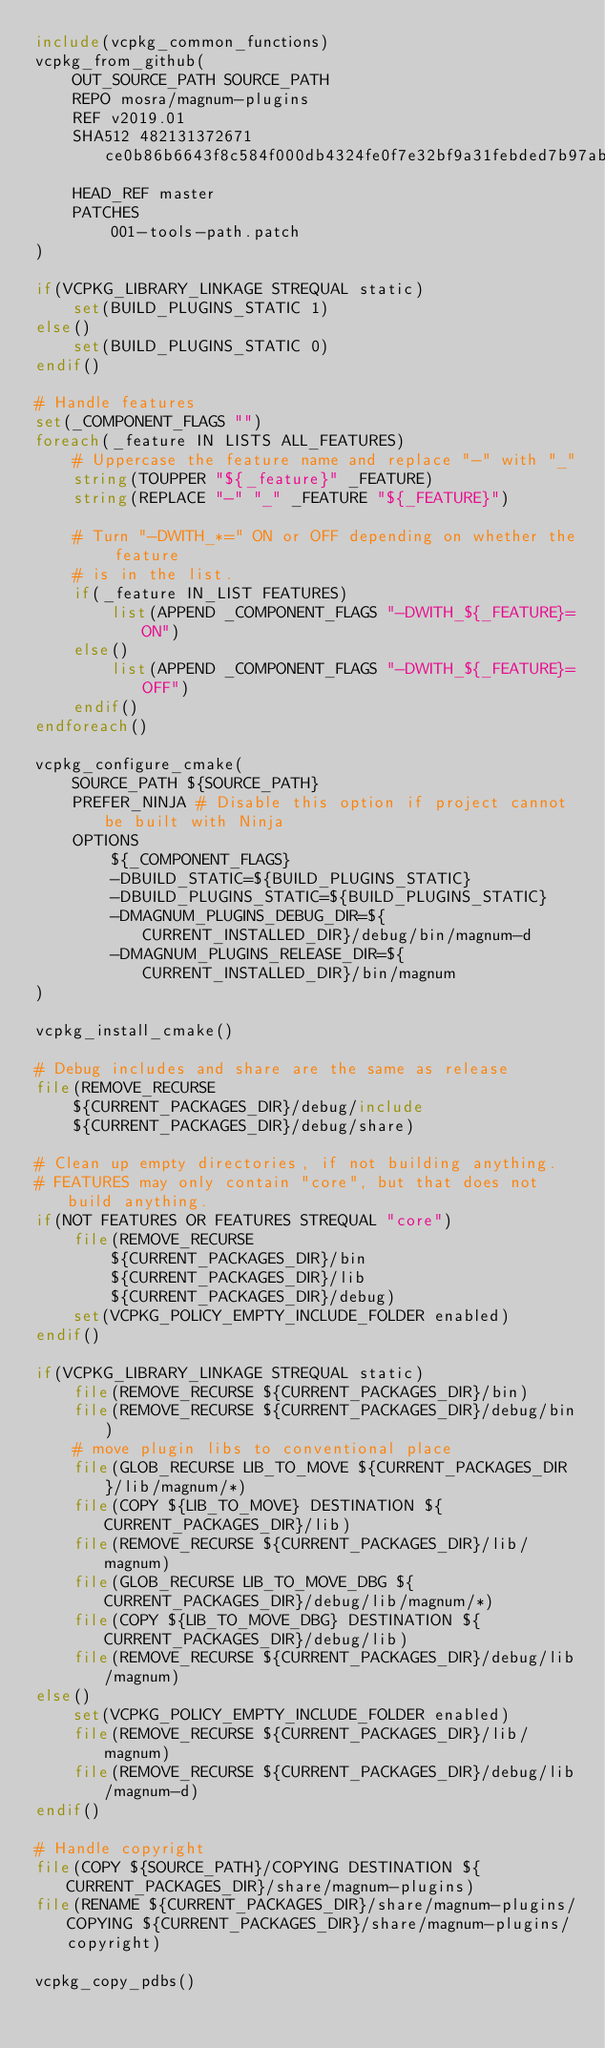Convert code to text. <code><loc_0><loc_0><loc_500><loc_500><_CMake_>include(vcpkg_common_functions)
vcpkg_from_github(
    OUT_SOURCE_PATH SOURCE_PATH
    REPO mosra/magnum-plugins
    REF v2019.01
    SHA512 482131372671ce0b86b6643f8c584f000db4324fe0f7e32bf9a31febded7b97ab7e947028fe21ce649554d2cff2bc11dfd94fad0006c465911c9f44b28c2d2a5
    HEAD_REF master
    PATCHES
        001-tools-path.patch
)

if(VCPKG_LIBRARY_LINKAGE STREQUAL static)
    set(BUILD_PLUGINS_STATIC 1)
else()
    set(BUILD_PLUGINS_STATIC 0)
endif()

# Handle features
set(_COMPONENT_FLAGS "")
foreach(_feature IN LISTS ALL_FEATURES)
    # Uppercase the feature name and replace "-" with "_"
    string(TOUPPER "${_feature}" _FEATURE)
    string(REPLACE "-" "_" _FEATURE "${_FEATURE}")

    # Turn "-DWITH_*=" ON or OFF depending on whether the feature
    # is in the list.
    if(_feature IN_LIST FEATURES)
        list(APPEND _COMPONENT_FLAGS "-DWITH_${_FEATURE}=ON")
    else()
        list(APPEND _COMPONENT_FLAGS "-DWITH_${_FEATURE}=OFF")
    endif()
endforeach()

vcpkg_configure_cmake(
    SOURCE_PATH ${SOURCE_PATH}
    PREFER_NINJA # Disable this option if project cannot be built with Ninja
    OPTIONS
        ${_COMPONENT_FLAGS}
        -DBUILD_STATIC=${BUILD_PLUGINS_STATIC}
        -DBUILD_PLUGINS_STATIC=${BUILD_PLUGINS_STATIC}
        -DMAGNUM_PLUGINS_DEBUG_DIR=${CURRENT_INSTALLED_DIR}/debug/bin/magnum-d
        -DMAGNUM_PLUGINS_RELEASE_DIR=${CURRENT_INSTALLED_DIR}/bin/magnum
)

vcpkg_install_cmake()

# Debug includes and share are the same as release
file(REMOVE_RECURSE
    ${CURRENT_PACKAGES_DIR}/debug/include
    ${CURRENT_PACKAGES_DIR}/debug/share)

# Clean up empty directories, if not building anything.
# FEATURES may only contain "core", but that does not build anything.
if(NOT FEATURES OR FEATURES STREQUAL "core")
    file(REMOVE_RECURSE
        ${CURRENT_PACKAGES_DIR}/bin
        ${CURRENT_PACKAGES_DIR}/lib
        ${CURRENT_PACKAGES_DIR}/debug)
    set(VCPKG_POLICY_EMPTY_INCLUDE_FOLDER enabled)
endif()

if(VCPKG_LIBRARY_LINKAGE STREQUAL static)
    file(REMOVE_RECURSE ${CURRENT_PACKAGES_DIR}/bin)
    file(REMOVE_RECURSE ${CURRENT_PACKAGES_DIR}/debug/bin)
    # move plugin libs to conventional place
    file(GLOB_RECURSE LIB_TO_MOVE ${CURRENT_PACKAGES_DIR}/lib/magnum/*)
    file(COPY ${LIB_TO_MOVE} DESTINATION ${CURRENT_PACKAGES_DIR}/lib)
    file(REMOVE_RECURSE ${CURRENT_PACKAGES_DIR}/lib/magnum)
    file(GLOB_RECURSE LIB_TO_MOVE_DBG ${CURRENT_PACKAGES_DIR}/debug/lib/magnum/*)
    file(COPY ${LIB_TO_MOVE_DBG} DESTINATION ${CURRENT_PACKAGES_DIR}/debug/lib)
    file(REMOVE_RECURSE ${CURRENT_PACKAGES_DIR}/debug/lib/magnum)
else()
    set(VCPKG_POLICY_EMPTY_INCLUDE_FOLDER enabled)
    file(REMOVE_RECURSE ${CURRENT_PACKAGES_DIR}/lib/magnum)
    file(REMOVE_RECURSE ${CURRENT_PACKAGES_DIR}/debug/lib/magnum-d)
endif()

# Handle copyright
file(COPY ${SOURCE_PATH}/COPYING DESTINATION ${CURRENT_PACKAGES_DIR}/share/magnum-plugins)
file(RENAME ${CURRENT_PACKAGES_DIR}/share/magnum-plugins/COPYING ${CURRENT_PACKAGES_DIR}/share/magnum-plugins/copyright)

vcpkg_copy_pdbs()
</code> 